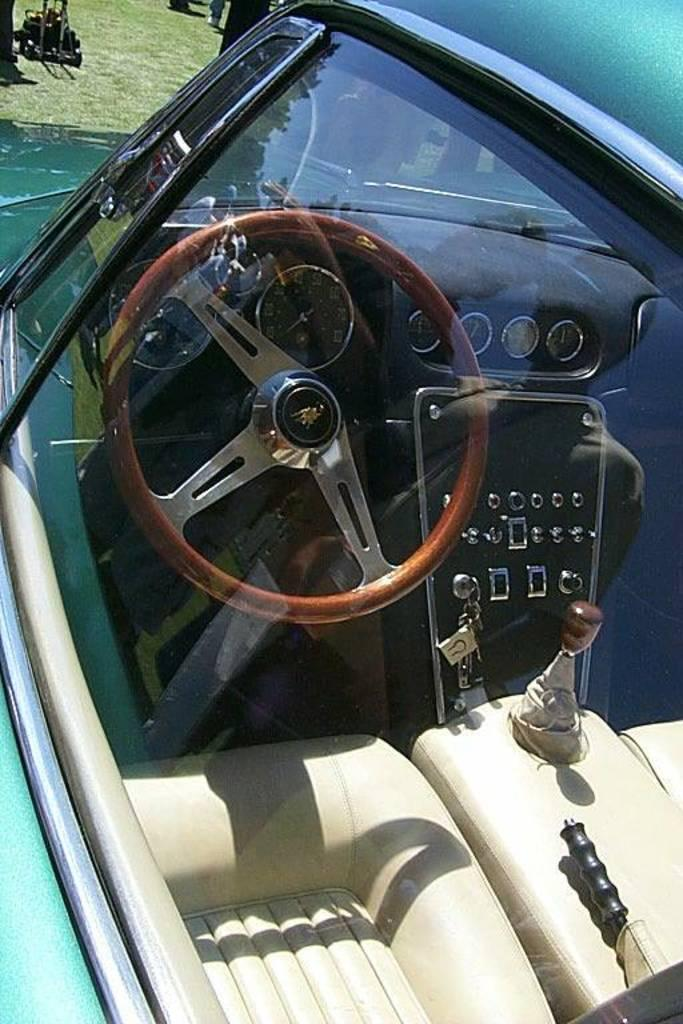What is the main subject of the image? The main subject of the image is a car. What can be seen inside the car through the glass? There are seats visible through the car's glass. What is used to control the car's speed and direction? The car has a gear and a steering wheel. How is the car started? The car has keys. What is used to monitor the car's performance? There are meters in the car. What is present on the ground at the top of the image? Grass is present on the ground at the top of the image. What type of instrument is being played by the minister in the image? There is no minister or instrument present in the image; it depicts a car. 